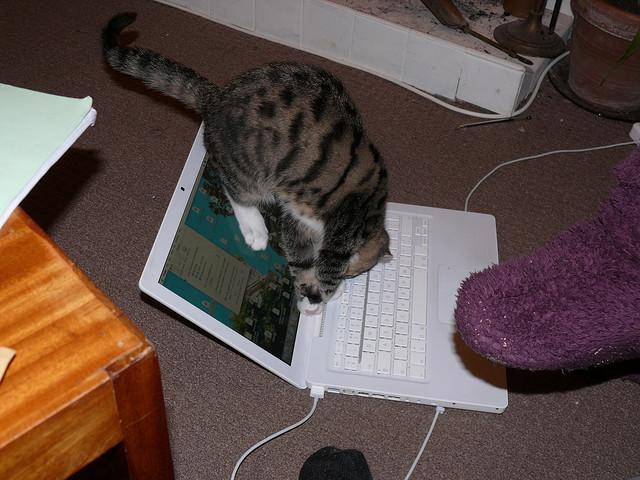How many shoes are there?
Give a very brief answer. 1. Is the cat using the laptop?
Concise answer only. No. Is the laptop turned on?
Be succinct. Yes. Is this animal heavy enough to damage the laptop?
Quick response, please. No. What color is the rug?
Answer briefly. Brown. Is the cat sleeping?
Concise answer only. Yes. Is the cat agitated?
Give a very brief answer. Yes. Can the owner of this laptop currently use it?
Be succinct. No. Is the cat looking at the camera?
Concise answer only. No. Does the owner of this cat enjoy Manga?
Answer briefly. No. 